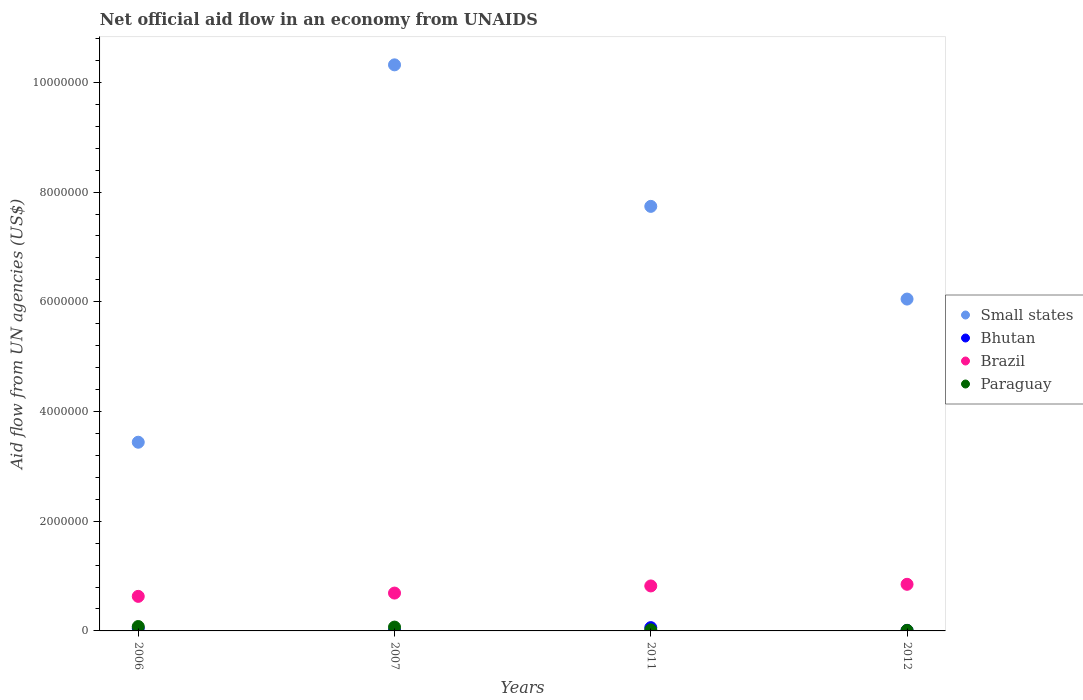How many different coloured dotlines are there?
Provide a short and direct response. 4. What is the net official aid flow in Bhutan in 2011?
Your answer should be very brief. 6.00e+04. Across all years, what is the maximum net official aid flow in Bhutan?
Your answer should be compact. 6.00e+04. In which year was the net official aid flow in Brazil minimum?
Provide a succinct answer. 2006. What is the total net official aid flow in Small states in the graph?
Give a very brief answer. 2.76e+07. What is the difference between the net official aid flow in Paraguay in 2006 and the net official aid flow in Bhutan in 2012?
Offer a very short reply. 7.00e+04. What is the average net official aid flow in Small states per year?
Offer a very short reply. 6.89e+06. In the year 2011, what is the difference between the net official aid flow in Bhutan and net official aid flow in Small states?
Your response must be concise. -7.68e+06. What is the ratio of the net official aid flow in Brazil in 2006 to that in 2011?
Offer a terse response. 0.77. Is the net official aid flow in Brazil in 2006 less than that in 2011?
Your answer should be very brief. Yes. What is the difference between the highest and the lowest net official aid flow in Small states?
Offer a very short reply. 6.88e+06. Is the sum of the net official aid flow in Bhutan in 2011 and 2012 greater than the maximum net official aid flow in Small states across all years?
Provide a succinct answer. No. Is it the case that in every year, the sum of the net official aid flow in Bhutan and net official aid flow in Brazil  is greater than the sum of net official aid flow in Paraguay and net official aid flow in Small states?
Your answer should be very brief. No. How many years are there in the graph?
Keep it short and to the point. 4. Does the graph contain grids?
Keep it short and to the point. No. How many legend labels are there?
Your answer should be compact. 4. How are the legend labels stacked?
Ensure brevity in your answer.  Vertical. What is the title of the graph?
Ensure brevity in your answer.  Net official aid flow in an economy from UNAIDS. Does "St. Kitts and Nevis" appear as one of the legend labels in the graph?
Ensure brevity in your answer.  No. What is the label or title of the X-axis?
Offer a terse response. Years. What is the label or title of the Y-axis?
Provide a short and direct response. Aid flow from UN agencies (US$). What is the Aid flow from UN agencies (US$) of Small states in 2006?
Your answer should be compact. 3.44e+06. What is the Aid flow from UN agencies (US$) of Brazil in 2006?
Offer a very short reply. 6.30e+05. What is the Aid flow from UN agencies (US$) in Paraguay in 2006?
Make the answer very short. 8.00e+04. What is the Aid flow from UN agencies (US$) in Small states in 2007?
Ensure brevity in your answer.  1.03e+07. What is the Aid flow from UN agencies (US$) in Brazil in 2007?
Give a very brief answer. 6.90e+05. What is the Aid flow from UN agencies (US$) of Paraguay in 2007?
Offer a terse response. 7.00e+04. What is the Aid flow from UN agencies (US$) of Small states in 2011?
Your answer should be very brief. 7.74e+06. What is the Aid flow from UN agencies (US$) in Brazil in 2011?
Ensure brevity in your answer.  8.20e+05. What is the Aid flow from UN agencies (US$) of Small states in 2012?
Offer a very short reply. 6.05e+06. What is the Aid flow from UN agencies (US$) in Bhutan in 2012?
Your answer should be very brief. 10000. What is the Aid flow from UN agencies (US$) in Brazil in 2012?
Provide a short and direct response. 8.50e+05. What is the Aid flow from UN agencies (US$) in Paraguay in 2012?
Your answer should be very brief. 10000. Across all years, what is the maximum Aid flow from UN agencies (US$) in Small states?
Your answer should be very brief. 1.03e+07. Across all years, what is the maximum Aid flow from UN agencies (US$) of Bhutan?
Make the answer very short. 6.00e+04. Across all years, what is the maximum Aid flow from UN agencies (US$) in Brazil?
Give a very brief answer. 8.50e+05. Across all years, what is the minimum Aid flow from UN agencies (US$) of Small states?
Ensure brevity in your answer.  3.44e+06. Across all years, what is the minimum Aid flow from UN agencies (US$) of Bhutan?
Ensure brevity in your answer.  10000. Across all years, what is the minimum Aid flow from UN agencies (US$) in Brazil?
Your answer should be compact. 6.30e+05. What is the total Aid flow from UN agencies (US$) of Small states in the graph?
Your answer should be compact. 2.76e+07. What is the total Aid flow from UN agencies (US$) of Bhutan in the graph?
Keep it short and to the point. 1.30e+05. What is the total Aid flow from UN agencies (US$) of Brazil in the graph?
Give a very brief answer. 2.99e+06. What is the difference between the Aid flow from UN agencies (US$) of Small states in 2006 and that in 2007?
Offer a very short reply. -6.88e+06. What is the difference between the Aid flow from UN agencies (US$) in Bhutan in 2006 and that in 2007?
Give a very brief answer. 4.00e+04. What is the difference between the Aid flow from UN agencies (US$) in Brazil in 2006 and that in 2007?
Your response must be concise. -6.00e+04. What is the difference between the Aid flow from UN agencies (US$) of Paraguay in 2006 and that in 2007?
Provide a succinct answer. 10000. What is the difference between the Aid flow from UN agencies (US$) in Small states in 2006 and that in 2011?
Make the answer very short. -4.30e+06. What is the difference between the Aid flow from UN agencies (US$) in Bhutan in 2006 and that in 2011?
Offer a terse response. -10000. What is the difference between the Aid flow from UN agencies (US$) in Brazil in 2006 and that in 2011?
Your answer should be compact. -1.90e+05. What is the difference between the Aid flow from UN agencies (US$) of Small states in 2006 and that in 2012?
Keep it short and to the point. -2.61e+06. What is the difference between the Aid flow from UN agencies (US$) of Bhutan in 2006 and that in 2012?
Your response must be concise. 4.00e+04. What is the difference between the Aid flow from UN agencies (US$) in Paraguay in 2006 and that in 2012?
Give a very brief answer. 7.00e+04. What is the difference between the Aid flow from UN agencies (US$) in Small states in 2007 and that in 2011?
Keep it short and to the point. 2.58e+06. What is the difference between the Aid flow from UN agencies (US$) of Paraguay in 2007 and that in 2011?
Offer a very short reply. 5.00e+04. What is the difference between the Aid flow from UN agencies (US$) in Small states in 2007 and that in 2012?
Offer a terse response. 4.27e+06. What is the difference between the Aid flow from UN agencies (US$) in Bhutan in 2007 and that in 2012?
Make the answer very short. 0. What is the difference between the Aid flow from UN agencies (US$) of Brazil in 2007 and that in 2012?
Give a very brief answer. -1.60e+05. What is the difference between the Aid flow from UN agencies (US$) of Paraguay in 2007 and that in 2012?
Your answer should be compact. 6.00e+04. What is the difference between the Aid flow from UN agencies (US$) in Small states in 2011 and that in 2012?
Give a very brief answer. 1.69e+06. What is the difference between the Aid flow from UN agencies (US$) in Bhutan in 2011 and that in 2012?
Offer a terse response. 5.00e+04. What is the difference between the Aid flow from UN agencies (US$) in Small states in 2006 and the Aid flow from UN agencies (US$) in Bhutan in 2007?
Your response must be concise. 3.43e+06. What is the difference between the Aid flow from UN agencies (US$) in Small states in 2006 and the Aid flow from UN agencies (US$) in Brazil in 2007?
Offer a very short reply. 2.75e+06. What is the difference between the Aid flow from UN agencies (US$) of Small states in 2006 and the Aid flow from UN agencies (US$) of Paraguay in 2007?
Offer a terse response. 3.37e+06. What is the difference between the Aid flow from UN agencies (US$) in Bhutan in 2006 and the Aid flow from UN agencies (US$) in Brazil in 2007?
Provide a succinct answer. -6.40e+05. What is the difference between the Aid flow from UN agencies (US$) of Brazil in 2006 and the Aid flow from UN agencies (US$) of Paraguay in 2007?
Make the answer very short. 5.60e+05. What is the difference between the Aid flow from UN agencies (US$) in Small states in 2006 and the Aid flow from UN agencies (US$) in Bhutan in 2011?
Your answer should be compact. 3.38e+06. What is the difference between the Aid flow from UN agencies (US$) of Small states in 2006 and the Aid flow from UN agencies (US$) of Brazil in 2011?
Give a very brief answer. 2.62e+06. What is the difference between the Aid flow from UN agencies (US$) in Small states in 2006 and the Aid flow from UN agencies (US$) in Paraguay in 2011?
Your answer should be compact. 3.42e+06. What is the difference between the Aid flow from UN agencies (US$) in Bhutan in 2006 and the Aid flow from UN agencies (US$) in Brazil in 2011?
Keep it short and to the point. -7.70e+05. What is the difference between the Aid flow from UN agencies (US$) in Small states in 2006 and the Aid flow from UN agencies (US$) in Bhutan in 2012?
Ensure brevity in your answer.  3.43e+06. What is the difference between the Aid flow from UN agencies (US$) of Small states in 2006 and the Aid flow from UN agencies (US$) of Brazil in 2012?
Your answer should be very brief. 2.59e+06. What is the difference between the Aid flow from UN agencies (US$) of Small states in 2006 and the Aid flow from UN agencies (US$) of Paraguay in 2012?
Give a very brief answer. 3.43e+06. What is the difference between the Aid flow from UN agencies (US$) in Bhutan in 2006 and the Aid flow from UN agencies (US$) in Brazil in 2012?
Offer a terse response. -8.00e+05. What is the difference between the Aid flow from UN agencies (US$) in Bhutan in 2006 and the Aid flow from UN agencies (US$) in Paraguay in 2012?
Provide a succinct answer. 4.00e+04. What is the difference between the Aid flow from UN agencies (US$) of Brazil in 2006 and the Aid flow from UN agencies (US$) of Paraguay in 2012?
Your answer should be very brief. 6.20e+05. What is the difference between the Aid flow from UN agencies (US$) in Small states in 2007 and the Aid flow from UN agencies (US$) in Bhutan in 2011?
Offer a terse response. 1.03e+07. What is the difference between the Aid flow from UN agencies (US$) in Small states in 2007 and the Aid flow from UN agencies (US$) in Brazil in 2011?
Your response must be concise. 9.50e+06. What is the difference between the Aid flow from UN agencies (US$) of Small states in 2007 and the Aid flow from UN agencies (US$) of Paraguay in 2011?
Make the answer very short. 1.03e+07. What is the difference between the Aid flow from UN agencies (US$) in Bhutan in 2007 and the Aid flow from UN agencies (US$) in Brazil in 2011?
Offer a terse response. -8.10e+05. What is the difference between the Aid flow from UN agencies (US$) in Brazil in 2007 and the Aid flow from UN agencies (US$) in Paraguay in 2011?
Your answer should be compact. 6.70e+05. What is the difference between the Aid flow from UN agencies (US$) of Small states in 2007 and the Aid flow from UN agencies (US$) of Bhutan in 2012?
Offer a very short reply. 1.03e+07. What is the difference between the Aid flow from UN agencies (US$) in Small states in 2007 and the Aid flow from UN agencies (US$) in Brazil in 2012?
Give a very brief answer. 9.47e+06. What is the difference between the Aid flow from UN agencies (US$) in Small states in 2007 and the Aid flow from UN agencies (US$) in Paraguay in 2012?
Offer a terse response. 1.03e+07. What is the difference between the Aid flow from UN agencies (US$) in Bhutan in 2007 and the Aid flow from UN agencies (US$) in Brazil in 2012?
Ensure brevity in your answer.  -8.40e+05. What is the difference between the Aid flow from UN agencies (US$) in Brazil in 2007 and the Aid flow from UN agencies (US$) in Paraguay in 2012?
Give a very brief answer. 6.80e+05. What is the difference between the Aid flow from UN agencies (US$) of Small states in 2011 and the Aid flow from UN agencies (US$) of Bhutan in 2012?
Give a very brief answer. 7.73e+06. What is the difference between the Aid flow from UN agencies (US$) in Small states in 2011 and the Aid flow from UN agencies (US$) in Brazil in 2012?
Give a very brief answer. 6.89e+06. What is the difference between the Aid flow from UN agencies (US$) in Small states in 2011 and the Aid flow from UN agencies (US$) in Paraguay in 2012?
Your answer should be compact. 7.73e+06. What is the difference between the Aid flow from UN agencies (US$) in Bhutan in 2011 and the Aid flow from UN agencies (US$) in Brazil in 2012?
Keep it short and to the point. -7.90e+05. What is the difference between the Aid flow from UN agencies (US$) of Bhutan in 2011 and the Aid flow from UN agencies (US$) of Paraguay in 2012?
Provide a short and direct response. 5.00e+04. What is the difference between the Aid flow from UN agencies (US$) in Brazil in 2011 and the Aid flow from UN agencies (US$) in Paraguay in 2012?
Give a very brief answer. 8.10e+05. What is the average Aid flow from UN agencies (US$) in Small states per year?
Offer a very short reply. 6.89e+06. What is the average Aid flow from UN agencies (US$) of Bhutan per year?
Provide a succinct answer. 3.25e+04. What is the average Aid flow from UN agencies (US$) of Brazil per year?
Your response must be concise. 7.48e+05. What is the average Aid flow from UN agencies (US$) in Paraguay per year?
Provide a short and direct response. 4.50e+04. In the year 2006, what is the difference between the Aid flow from UN agencies (US$) in Small states and Aid flow from UN agencies (US$) in Bhutan?
Keep it short and to the point. 3.39e+06. In the year 2006, what is the difference between the Aid flow from UN agencies (US$) of Small states and Aid flow from UN agencies (US$) of Brazil?
Provide a succinct answer. 2.81e+06. In the year 2006, what is the difference between the Aid flow from UN agencies (US$) of Small states and Aid flow from UN agencies (US$) of Paraguay?
Make the answer very short. 3.36e+06. In the year 2006, what is the difference between the Aid flow from UN agencies (US$) in Bhutan and Aid flow from UN agencies (US$) in Brazil?
Give a very brief answer. -5.80e+05. In the year 2006, what is the difference between the Aid flow from UN agencies (US$) of Brazil and Aid flow from UN agencies (US$) of Paraguay?
Offer a terse response. 5.50e+05. In the year 2007, what is the difference between the Aid flow from UN agencies (US$) of Small states and Aid flow from UN agencies (US$) of Bhutan?
Your answer should be very brief. 1.03e+07. In the year 2007, what is the difference between the Aid flow from UN agencies (US$) in Small states and Aid flow from UN agencies (US$) in Brazil?
Ensure brevity in your answer.  9.63e+06. In the year 2007, what is the difference between the Aid flow from UN agencies (US$) in Small states and Aid flow from UN agencies (US$) in Paraguay?
Offer a very short reply. 1.02e+07. In the year 2007, what is the difference between the Aid flow from UN agencies (US$) of Bhutan and Aid flow from UN agencies (US$) of Brazil?
Ensure brevity in your answer.  -6.80e+05. In the year 2007, what is the difference between the Aid flow from UN agencies (US$) of Brazil and Aid flow from UN agencies (US$) of Paraguay?
Make the answer very short. 6.20e+05. In the year 2011, what is the difference between the Aid flow from UN agencies (US$) in Small states and Aid flow from UN agencies (US$) in Bhutan?
Keep it short and to the point. 7.68e+06. In the year 2011, what is the difference between the Aid flow from UN agencies (US$) of Small states and Aid flow from UN agencies (US$) of Brazil?
Offer a terse response. 6.92e+06. In the year 2011, what is the difference between the Aid flow from UN agencies (US$) of Small states and Aid flow from UN agencies (US$) of Paraguay?
Provide a succinct answer. 7.72e+06. In the year 2011, what is the difference between the Aid flow from UN agencies (US$) of Bhutan and Aid flow from UN agencies (US$) of Brazil?
Ensure brevity in your answer.  -7.60e+05. In the year 2011, what is the difference between the Aid flow from UN agencies (US$) of Bhutan and Aid flow from UN agencies (US$) of Paraguay?
Provide a short and direct response. 4.00e+04. In the year 2012, what is the difference between the Aid flow from UN agencies (US$) of Small states and Aid flow from UN agencies (US$) of Bhutan?
Provide a succinct answer. 6.04e+06. In the year 2012, what is the difference between the Aid flow from UN agencies (US$) of Small states and Aid flow from UN agencies (US$) of Brazil?
Ensure brevity in your answer.  5.20e+06. In the year 2012, what is the difference between the Aid flow from UN agencies (US$) in Small states and Aid flow from UN agencies (US$) in Paraguay?
Provide a succinct answer. 6.04e+06. In the year 2012, what is the difference between the Aid flow from UN agencies (US$) of Bhutan and Aid flow from UN agencies (US$) of Brazil?
Provide a short and direct response. -8.40e+05. In the year 2012, what is the difference between the Aid flow from UN agencies (US$) of Bhutan and Aid flow from UN agencies (US$) of Paraguay?
Ensure brevity in your answer.  0. In the year 2012, what is the difference between the Aid flow from UN agencies (US$) of Brazil and Aid flow from UN agencies (US$) of Paraguay?
Your answer should be very brief. 8.40e+05. What is the ratio of the Aid flow from UN agencies (US$) in Small states in 2006 to that in 2007?
Provide a succinct answer. 0.33. What is the ratio of the Aid flow from UN agencies (US$) of Bhutan in 2006 to that in 2007?
Your response must be concise. 5. What is the ratio of the Aid flow from UN agencies (US$) in Paraguay in 2006 to that in 2007?
Ensure brevity in your answer.  1.14. What is the ratio of the Aid flow from UN agencies (US$) in Small states in 2006 to that in 2011?
Provide a short and direct response. 0.44. What is the ratio of the Aid flow from UN agencies (US$) in Bhutan in 2006 to that in 2011?
Ensure brevity in your answer.  0.83. What is the ratio of the Aid flow from UN agencies (US$) in Brazil in 2006 to that in 2011?
Your answer should be compact. 0.77. What is the ratio of the Aid flow from UN agencies (US$) of Paraguay in 2006 to that in 2011?
Your answer should be very brief. 4. What is the ratio of the Aid flow from UN agencies (US$) of Small states in 2006 to that in 2012?
Your response must be concise. 0.57. What is the ratio of the Aid flow from UN agencies (US$) in Bhutan in 2006 to that in 2012?
Ensure brevity in your answer.  5. What is the ratio of the Aid flow from UN agencies (US$) in Brazil in 2006 to that in 2012?
Provide a short and direct response. 0.74. What is the ratio of the Aid flow from UN agencies (US$) of Paraguay in 2006 to that in 2012?
Give a very brief answer. 8. What is the ratio of the Aid flow from UN agencies (US$) of Brazil in 2007 to that in 2011?
Offer a terse response. 0.84. What is the ratio of the Aid flow from UN agencies (US$) in Paraguay in 2007 to that in 2011?
Your response must be concise. 3.5. What is the ratio of the Aid flow from UN agencies (US$) in Small states in 2007 to that in 2012?
Give a very brief answer. 1.71. What is the ratio of the Aid flow from UN agencies (US$) of Brazil in 2007 to that in 2012?
Provide a succinct answer. 0.81. What is the ratio of the Aid flow from UN agencies (US$) of Small states in 2011 to that in 2012?
Your answer should be compact. 1.28. What is the ratio of the Aid flow from UN agencies (US$) of Brazil in 2011 to that in 2012?
Provide a short and direct response. 0.96. What is the ratio of the Aid flow from UN agencies (US$) in Paraguay in 2011 to that in 2012?
Provide a succinct answer. 2. What is the difference between the highest and the second highest Aid flow from UN agencies (US$) of Small states?
Keep it short and to the point. 2.58e+06. What is the difference between the highest and the second highest Aid flow from UN agencies (US$) in Paraguay?
Offer a very short reply. 10000. What is the difference between the highest and the lowest Aid flow from UN agencies (US$) in Small states?
Make the answer very short. 6.88e+06. 